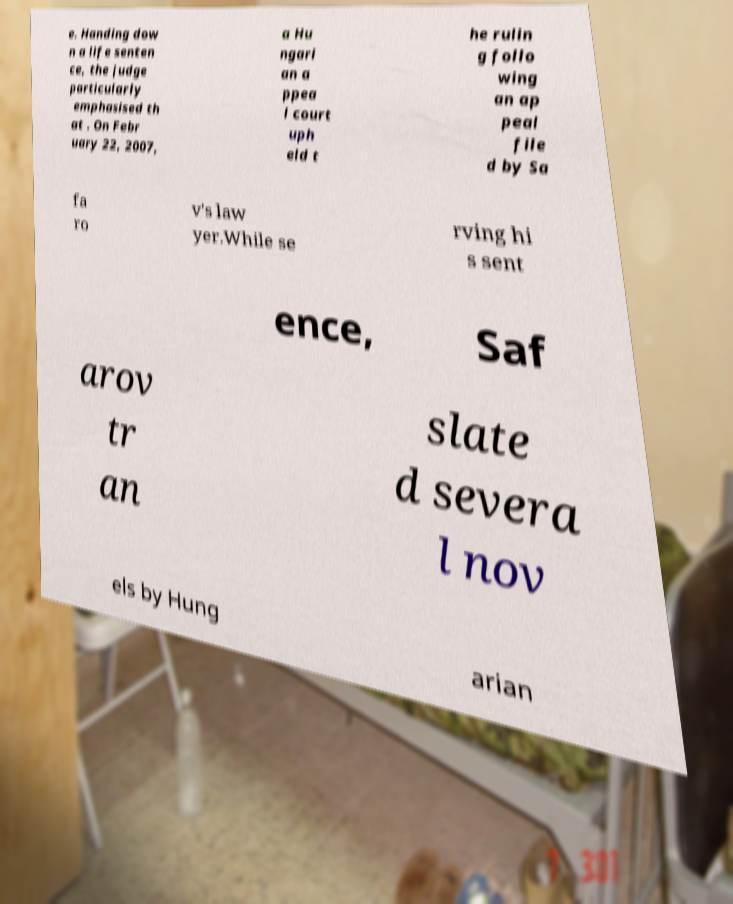There's text embedded in this image that I need extracted. Can you transcribe it verbatim? e. Handing dow n a life senten ce, the judge particularly emphasised th at . On Febr uary 22, 2007, a Hu ngari an a ppea l court uph eld t he rulin g follo wing an ap peal file d by Sa fa ro v's law yer.While se rving hi s sent ence, Saf arov tr an slate d severa l nov els by Hung arian 